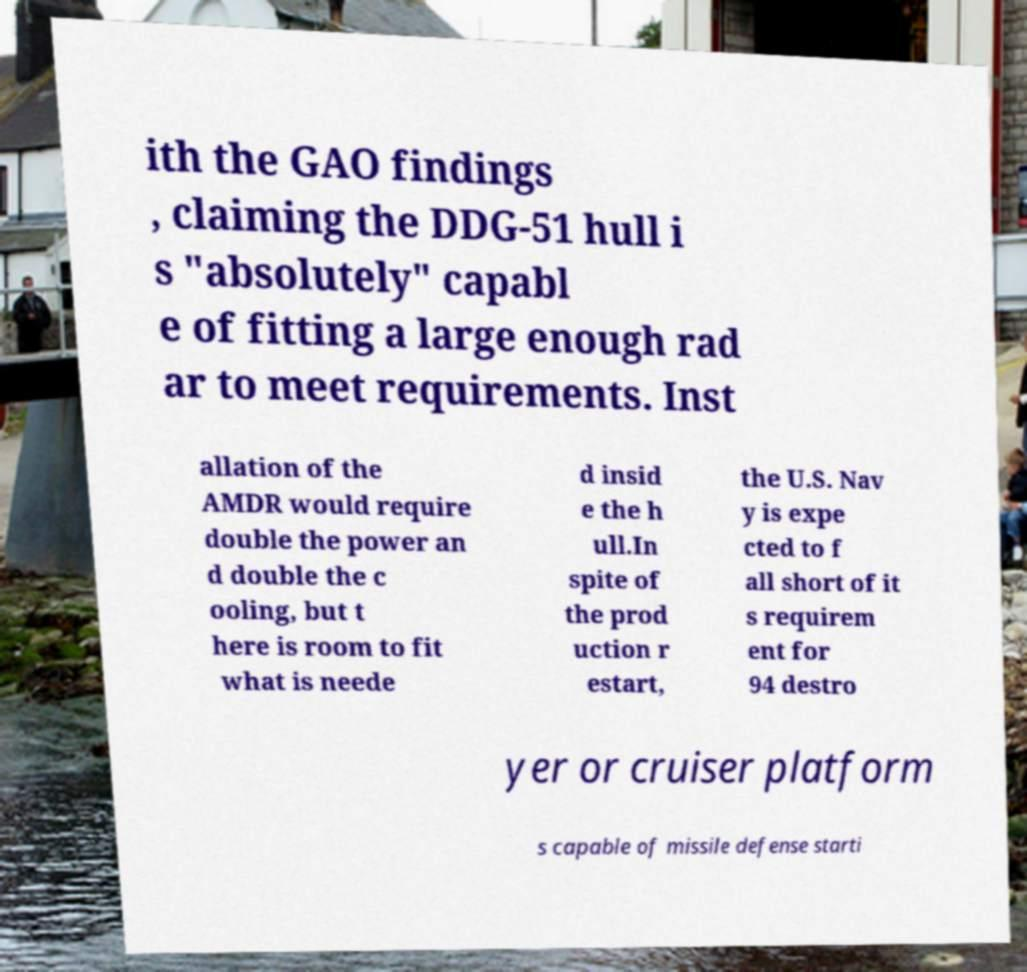For documentation purposes, I need the text within this image transcribed. Could you provide that? ith the GAO findings , claiming the DDG-51 hull i s "absolutely" capabl e of fitting a large enough rad ar to meet requirements. Inst allation of the AMDR would require double the power an d double the c ooling, but t here is room to fit what is neede d insid e the h ull.In spite of the prod uction r estart, the U.S. Nav y is expe cted to f all short of it s requirem ent for 94 destro yer or cruiser platform s capable of missile defense starti 